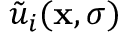Convert formula to latex. <formula><loc_0><loc_0><loc_500><loc_500>\tilde { u } _ { i } ( { x } , \sigma )</formula> 